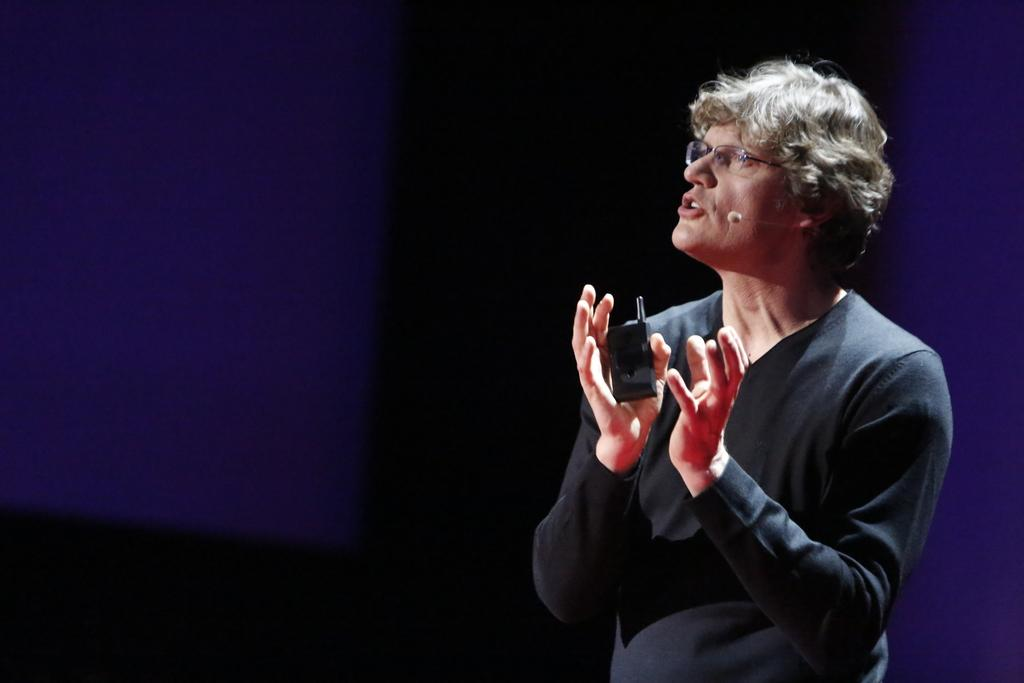Who is the main subject in the image? There is a woman in the image. Where is the woman positioned in the image? The woman is standing on the right side of the image. What is the woman wearing? The woman is wearing a black dress. What object is the woman holding in the image? The woman is holding a mobile phone. What is the color of the mobile phone? The mobile phone is black in color. What accessory is the woman wearing on her face? The woman is wearing spectacles. What type of food is the woman eating in the image? There is no food visible in the image, and the woman is not shown eating anything. How many units of time are displayed on the clocks in the image? There are no clocks present in the image. 